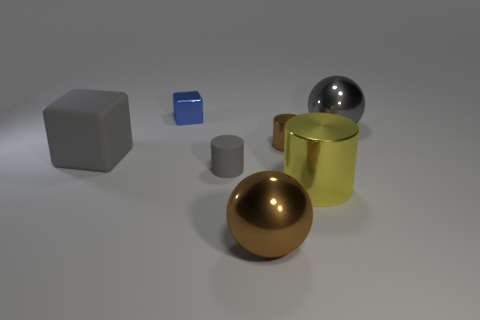Subtract 1 cylinders. How many cylinders are left? 2 Add 2 yellow things. How many objects exist? 9 Subtract all balls. How many objects are left? 5 Subtract all tiny brown spheres. Subtract all brown spheres. How many objects are left? 6 Add 4 tiny cylinders. How many tiny cylinders are left? 6 Add 5 large shiny spheres. How many large shiny spheres exist? 7 Subtract 1 gray balls. How many objects are left? 6 